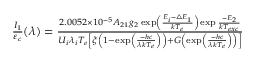<formula> <loc_0><loc_0><loc_500><loc_500>\begin{array} { r } { \frac { I _ { 1 } } { \varepsilon _ { c } } ( \lambda ) = \frac { 2 . 0 0 5 2 \times 1 0 ^ { - 5 } A _ { 2 1 } g _ { 2 } \exp \left ( \frac { E _ { i } - \bigtriangleup E _ { 1 } } { k T _ { e } } \right ) \exp \frac { - E _ { 2 } } { k T _ { e x c } } } { U _ { i } \lambda _ { i } T _ { e } \left [ \xi \left ( 1 - \exp \left ( \frac { - h c } { \lambda k T _ { e } } \right ) \right ) + G \left ( \exp \left ( \frac { - h c } { \lambda k T _ { e } } \right ) \right ) \right ] } } \end{array}</formula> 